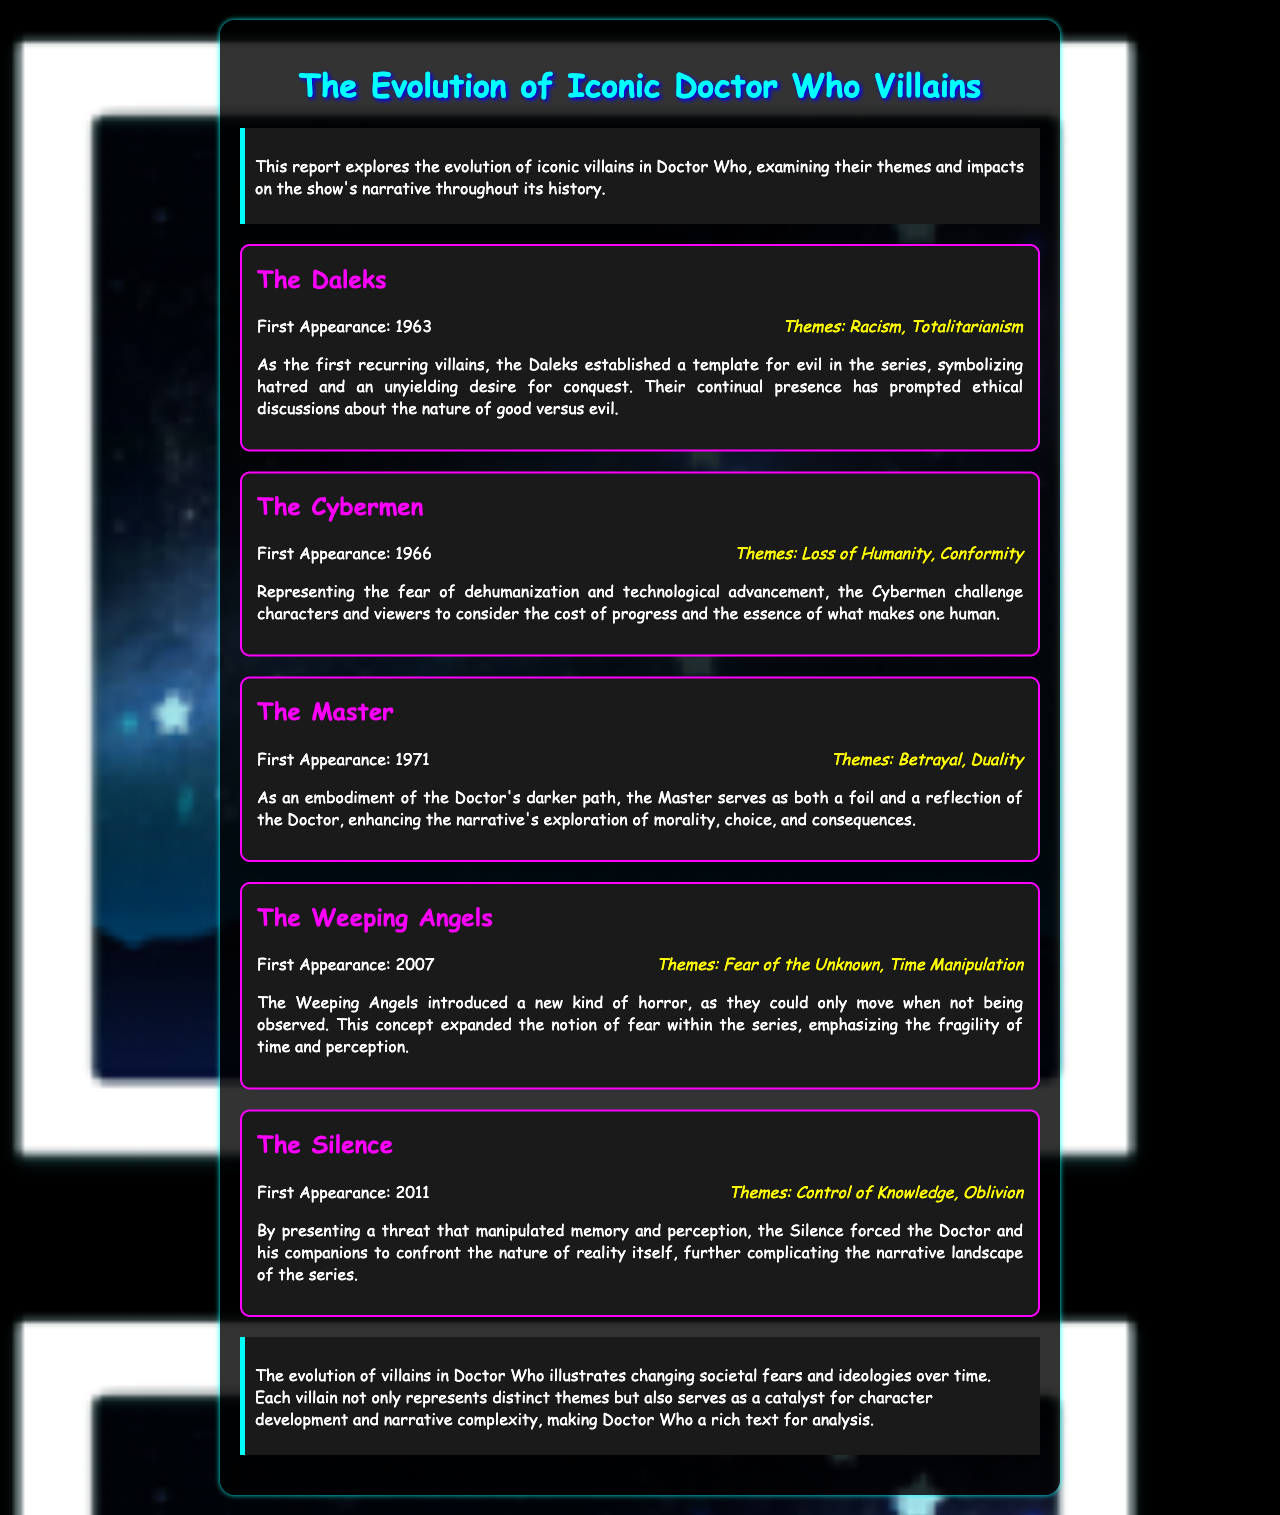What is the first appearance year of the Daleks? The first appearance of the Daleks is mentioned in the document as occurring in 1963.
Answer: 1963 What themes are associated with the Cybermen? The document lists the themes associated with the Cybermen as "Loss of Humanity, Conformity."
Answer: Loss of Humanity, Conformity Who serves as a foil to the Doctor according to the document? The document states that the Master serves as an embodiment of the Doctor's darker path and a foil to the Doctor.
Answer: The Master What is the first appearance year of the Weeping Angels? The year of the first appearance of the Weeping Angels is noted in the document as 2007.
Answer: 2007 Which villain introduced the theme of "Fear of the Unknown"? According to the document, the Weeping Angels introduced the theme of "Fear of the Unknown."
Answer: The Weeping Angels How do the Silence manipulate perception? The document explains that the Silence manipulate memory and perception, presenting a threat.
Answer: Memory and perception What theme is represented by the Daleks? The document states that the Daleks represent themes of "Racism, Totalitarianism."
Answer: Racism, Totalitarianism What narrative aspect do the villains exemplify throughout the report? The report emphasizes that the evolution of villains illustrates changing societal fears and ideologies.
Answer: Changing societal fears and ideologies What does the conclusion of the report state about the villains' role? The conclusion notes that each villain serves as a catalyst for character development and narrative complexity.
Answer: Catalyst for character development and narrative complexity 